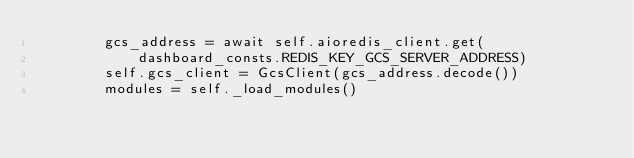<code> <loc_0><loc_0><loc_500><loc_500><_Python_>        gcs_address = await self.aioredis_client.get(
            dashboard_consts.REDIS_KEY_GCS_SERVER_ADDRESS)
        self.gcs_client = GcsClient(gcs_address.decode())
        modules = self._load_modules()
</code> 